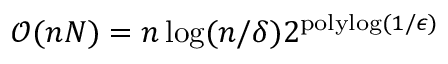<formula> <loc_0><loc_0><loc_500><loc_500>\mathcal { O } ( n N ) = n \log ( n / \delta ) 2 ^ { p o l y \log ( 1 / \epsilon ) }</formula> 